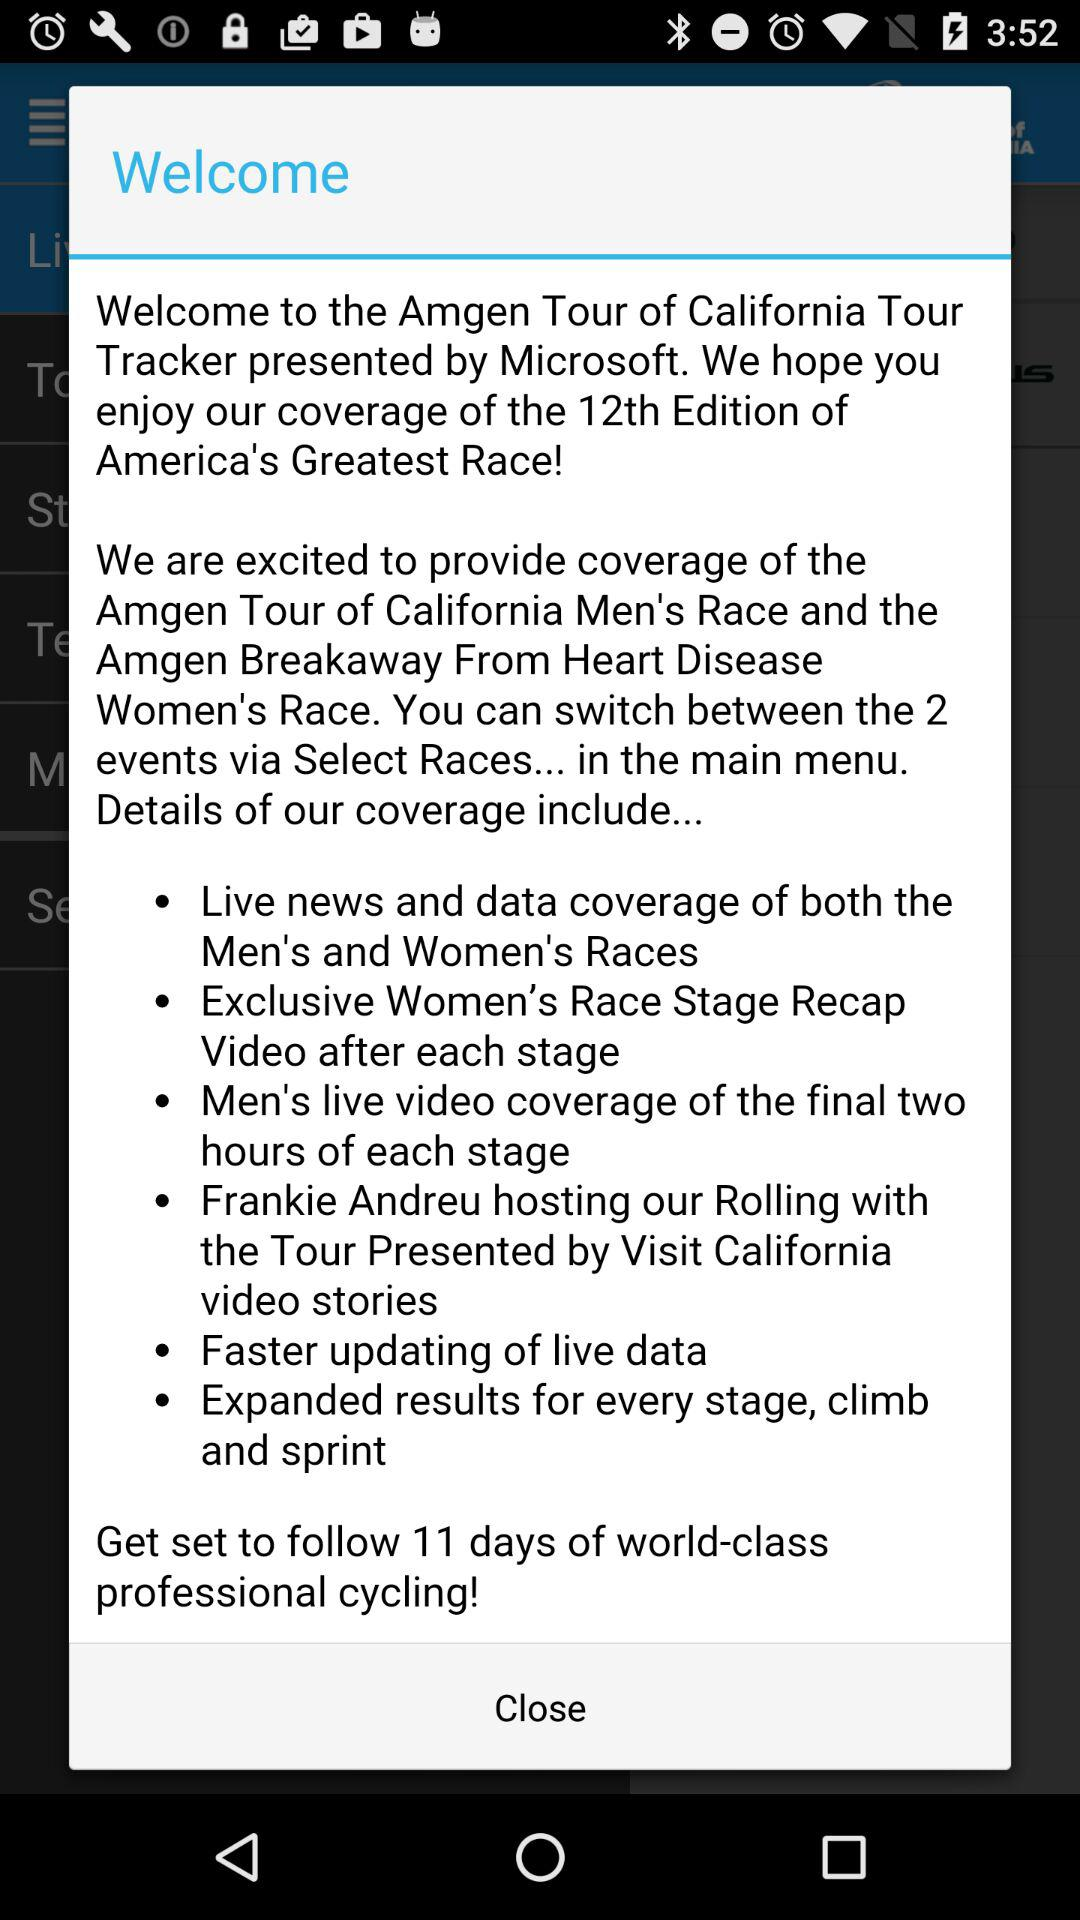Who presents this event? The event is presented by Microsoft. 